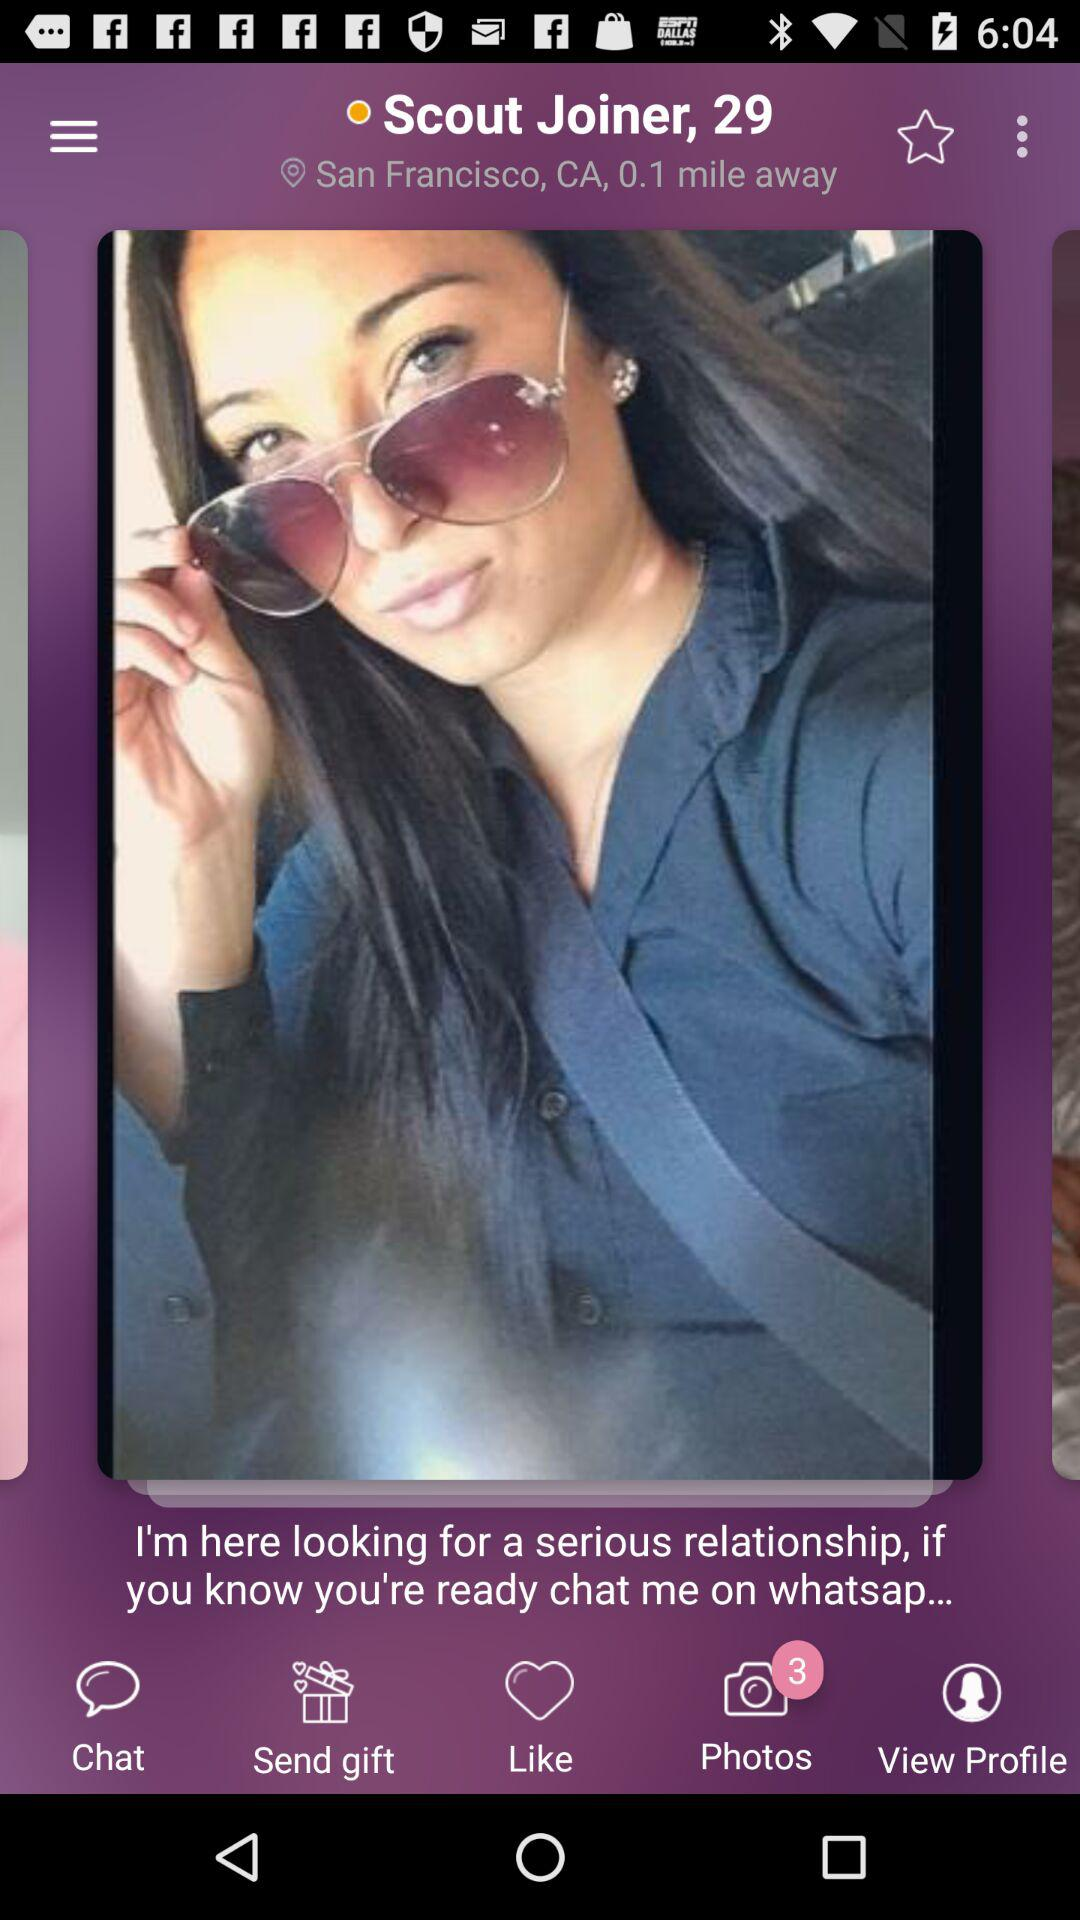How many miles is the person away from San Francisco? The person is 0.1 mile away. 